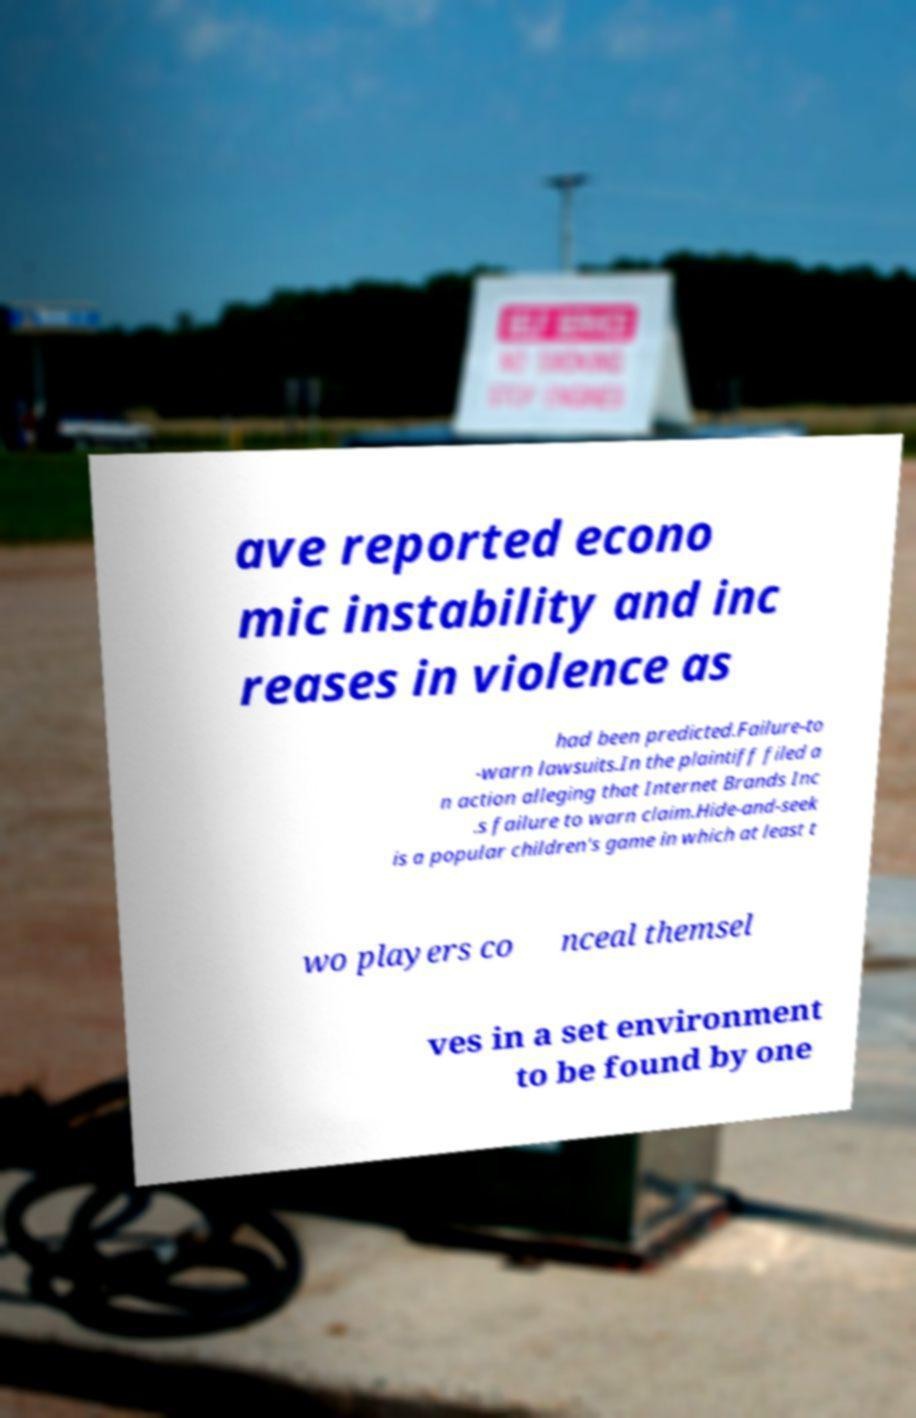Can you read and provide the text displayed in the image?This photo seems to have some interesting text. Can you extract and type it out for me? ave reported econo mic instability and inc reases in violence as had been predicted.Failure-to -warn lawsuits.In the plaintiff filed a n action alleging that Internet Brands Inc .s failure to warn claim.Hide-and-seek is a popular children's game in which at least t wo players co nceal themsel ves in a set environment to be found by one 